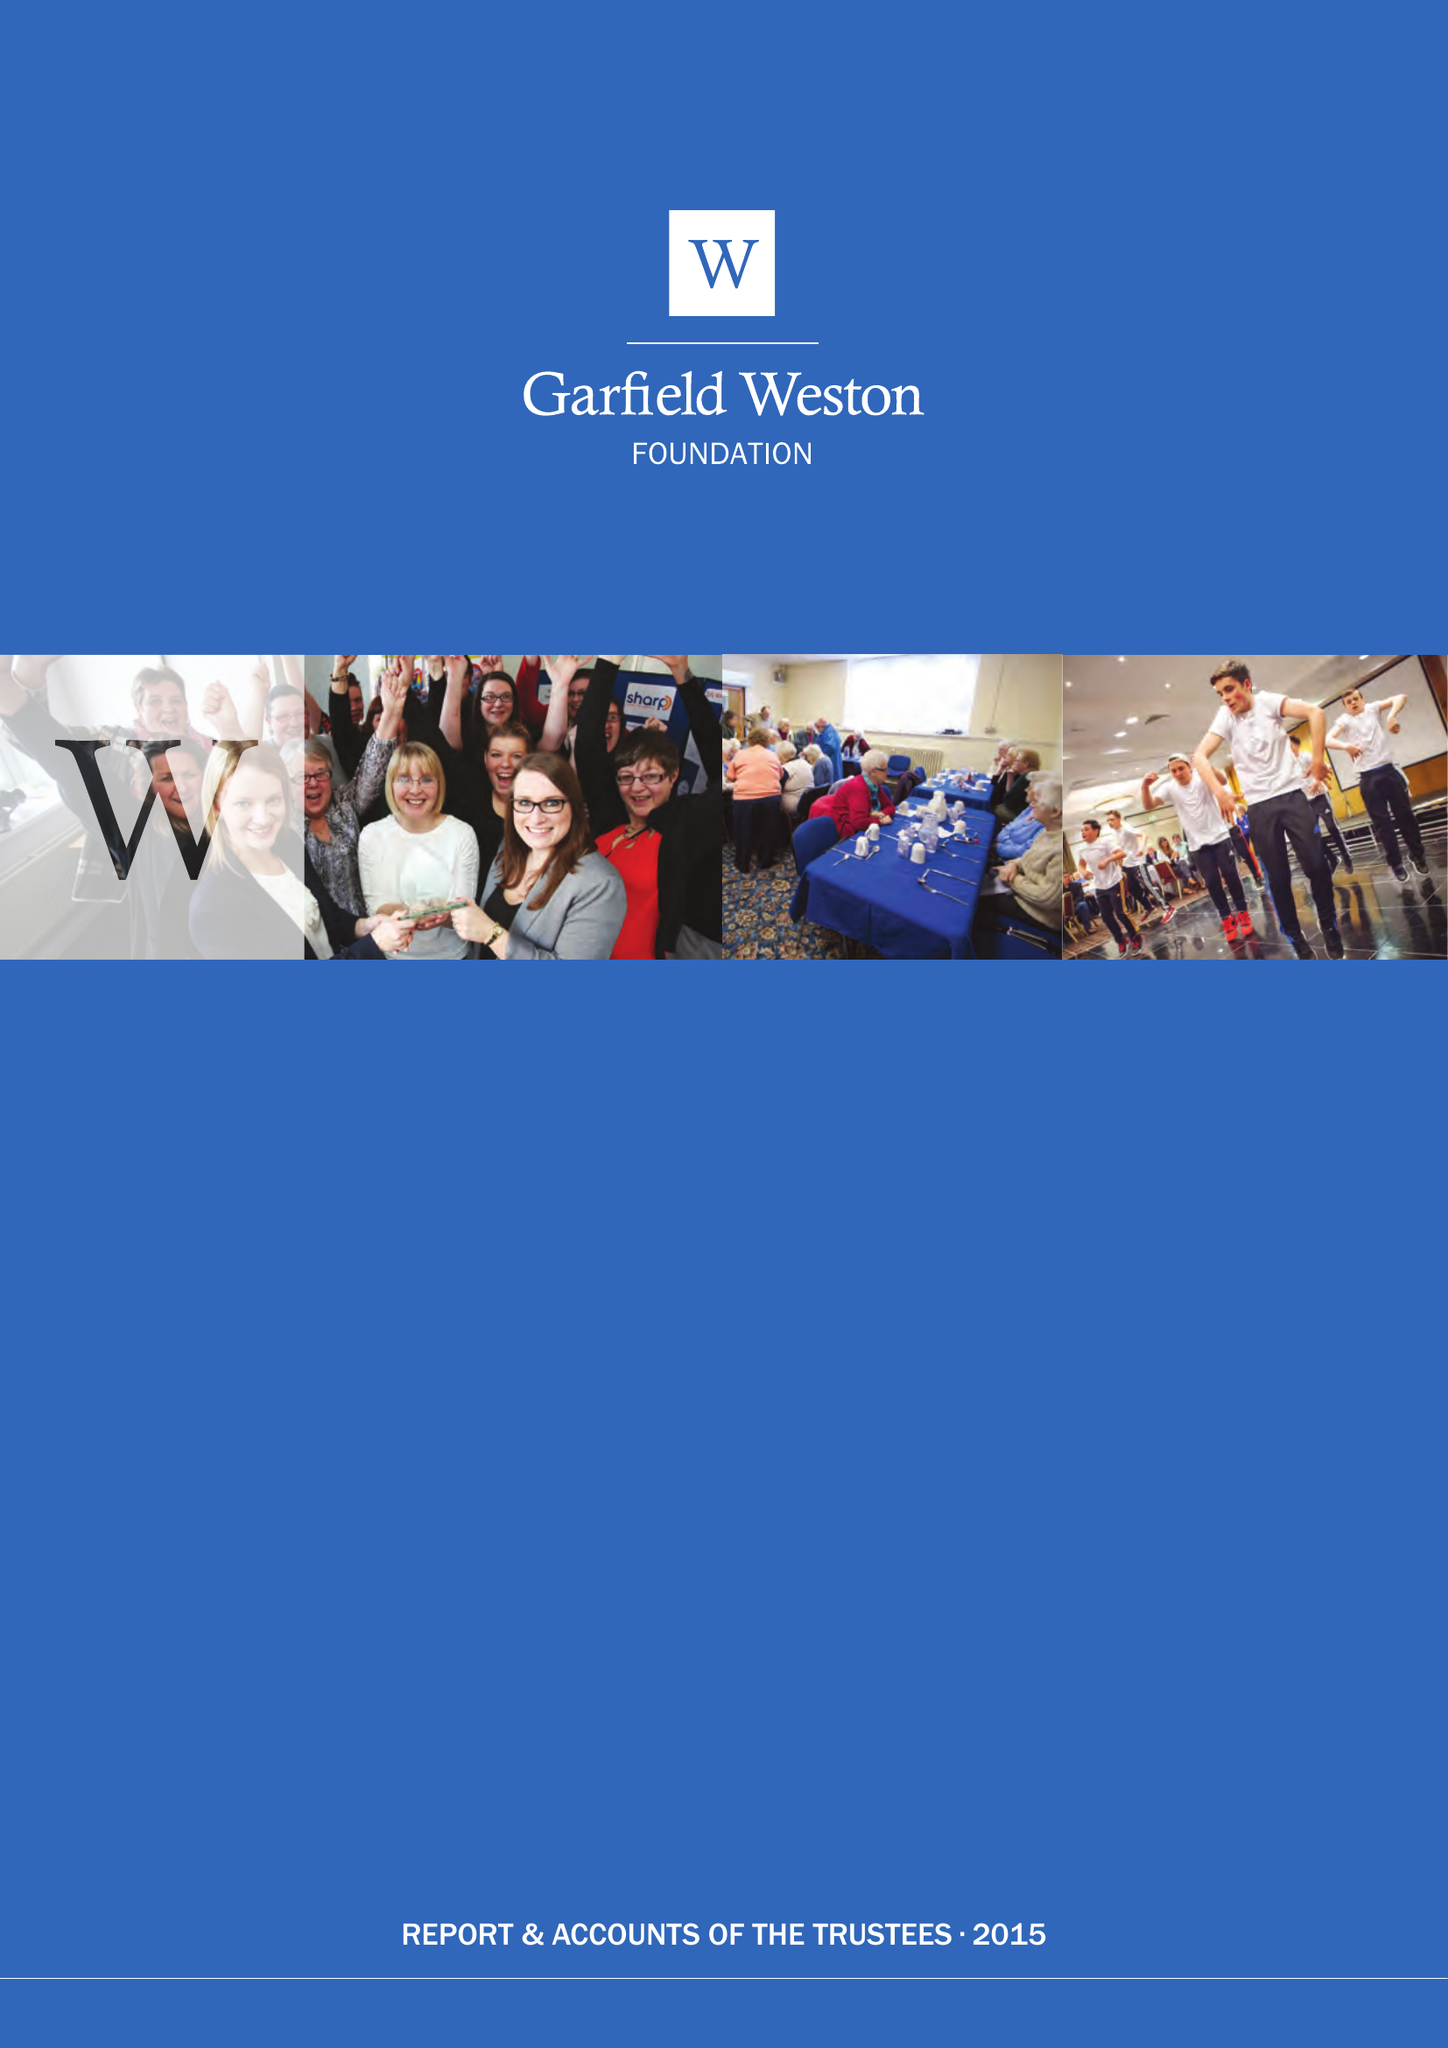What is the value for the income_annually_in_british_pounds?
Answer the question using a single word or phrase. 56611000.00 